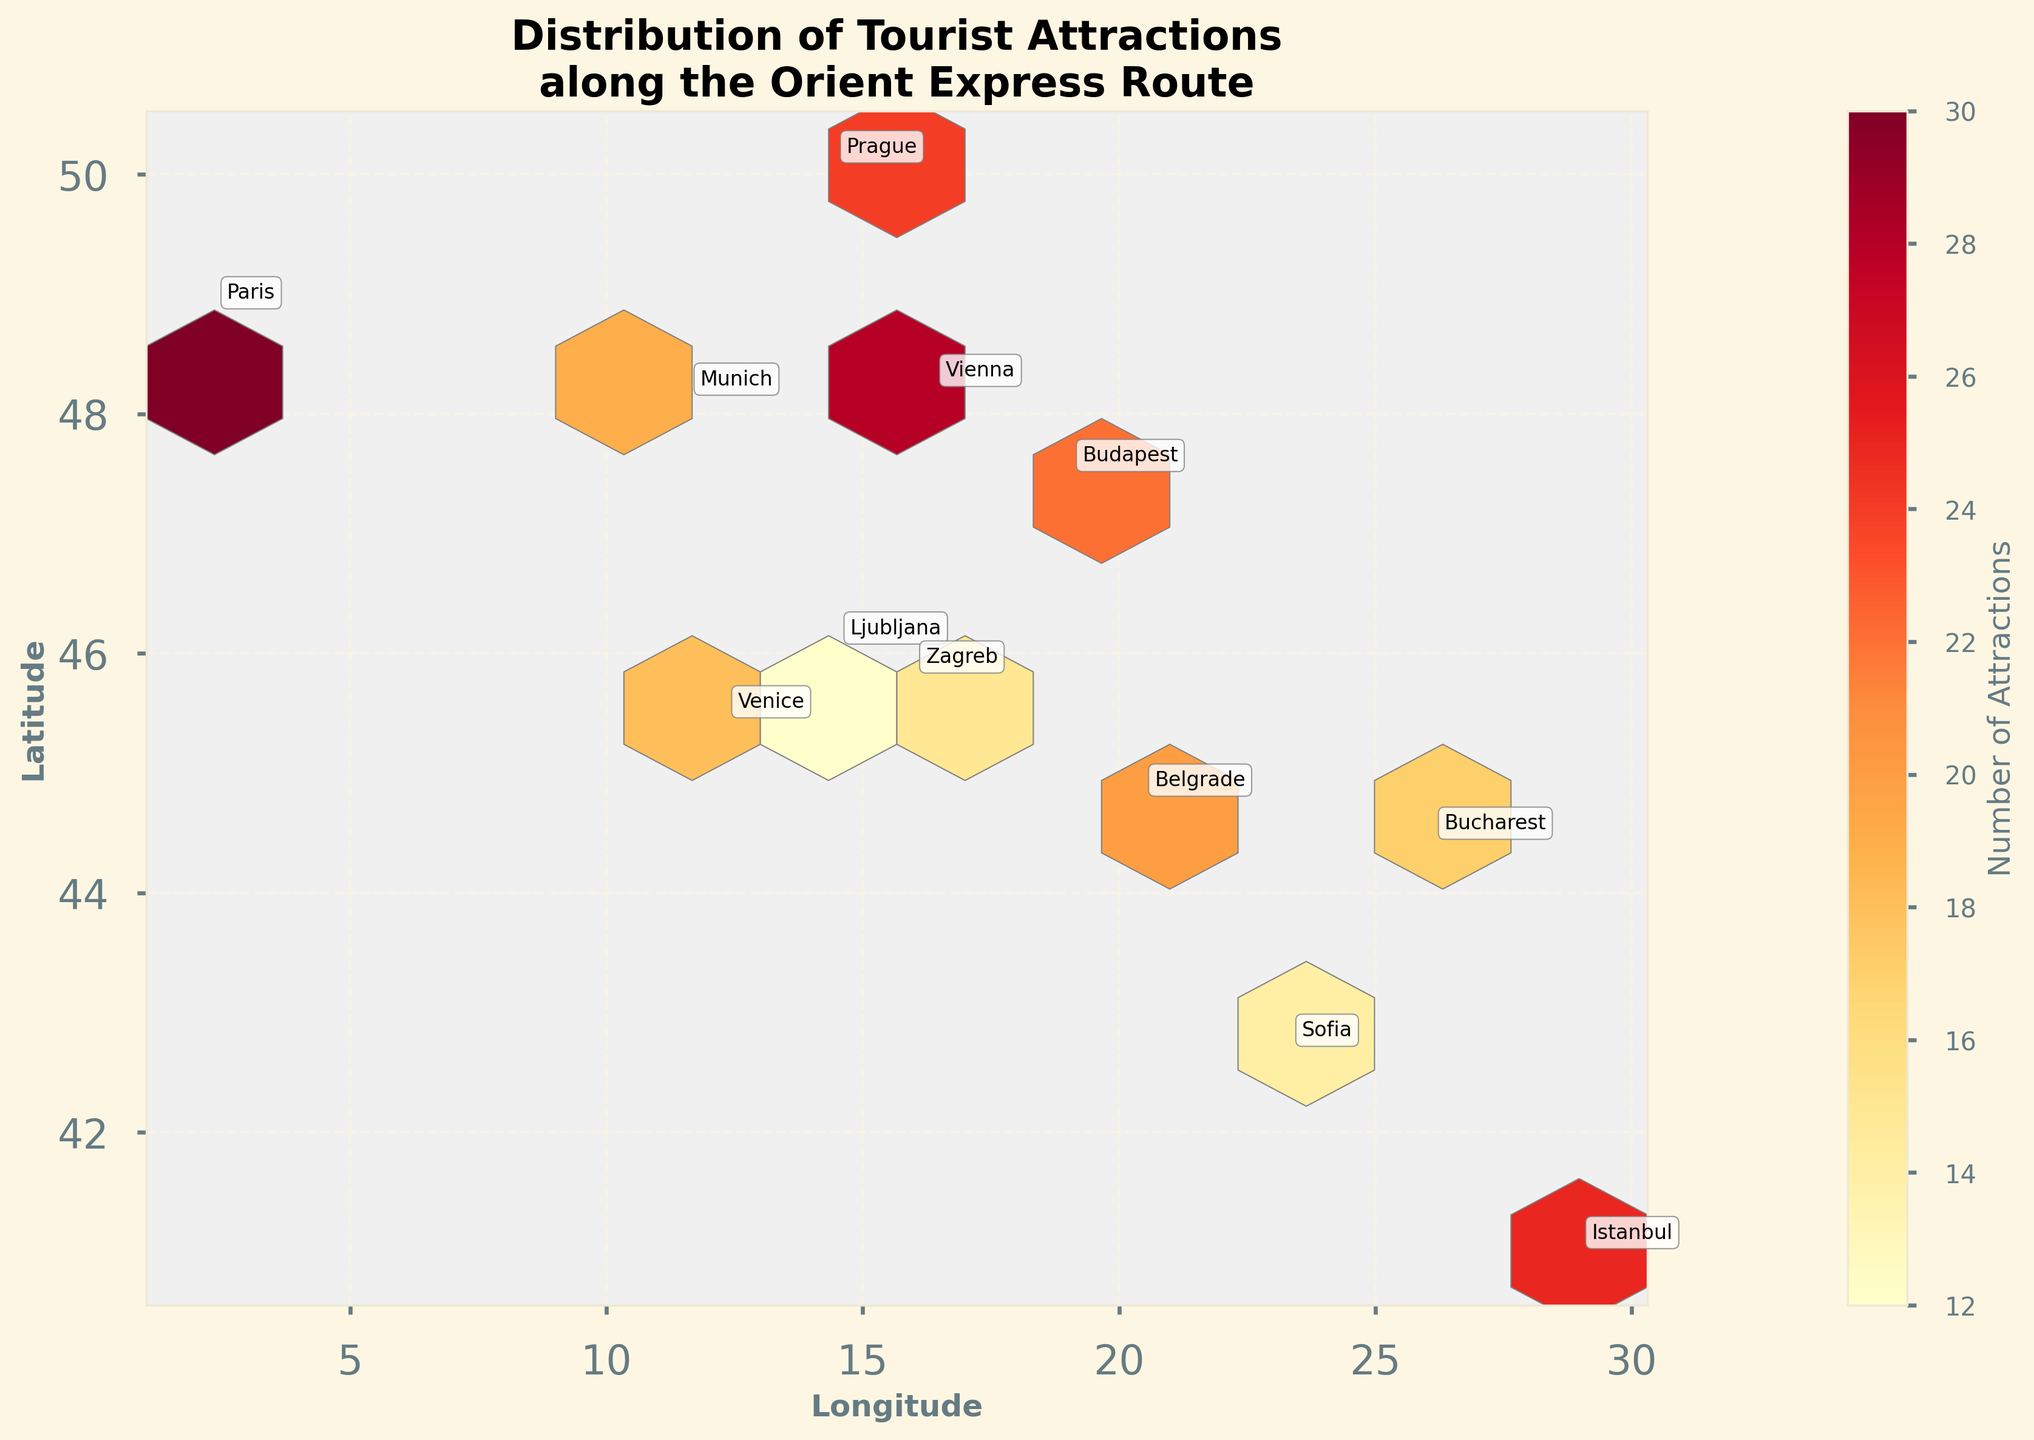What is the title of the figure? The title is displayed prominently at the top of the plot. It reads "Distribution of Tourist Attractions along the Orient Express Route" with a subtitle.
Answer: Distribution of Tourist Attractions along the Orient Express Route Which station has the highest number of tourist attractions? By looking at the color legend for the number of attractions, Paris has the deepest color indicating the highest value, which is 30 attractions.
Answer: Paris How many stations have more than 20 tourist attractions within a 5-mile radius? By examining the color intensity and the value annotations, Vienna, Prague, Paris, and Budapest each have more than 20 attractions. That's four stations.
Answer: 4 stations What is the latitude and longitude of Istanbul? The plot has annotated station names near each geographic point. Istanbul is located at latitude 41.0082 and longitude 28.9784.
Answer: 41.0082, 28.9784 Which station is located furthest west? The station with the lowest longitude value represents the furthest west. According to the plot's annotations, Paris is the furthest west.
Answer: Paris Which station has fewer attractions: Zagreb or Sofia? Comparing the color intensities and the attraction count annotations directly, Zagreb has 15 attractions while Sofia has 14. Therefore, Sofia has fewer attractions.
Answer: Sofia Are there more tourist attractions at Venice or Munich? Referring to the attraction count annotations and the color intensities, Venice has 18 attractions and Munich has 19. Munich has more attractions.
Answer: Munich Which station is located at approximately 45 degrees latitude? The station annotations pinpoint the locations. Both Venice and Zagreb are very close to 45 degrees latitude, but Venezia (Venice - 45.4408) is more precisely on that line.
Answer: Venice What is the general latitudinal trend of the stations along the Orient Express route? Observing the y-axis of the plot, stations generally increase in latitude from south to north starting from Istanbul moving towards Paris and Prague in the north.
Answer: South to North How is tourist attraction density represented in the plot? Tourist attraction density is represented using color intensities in the hexagonal bins, with darker colors indicating a higher density of attractions.
Answer: Color intensities in hexagonal bins represent density 